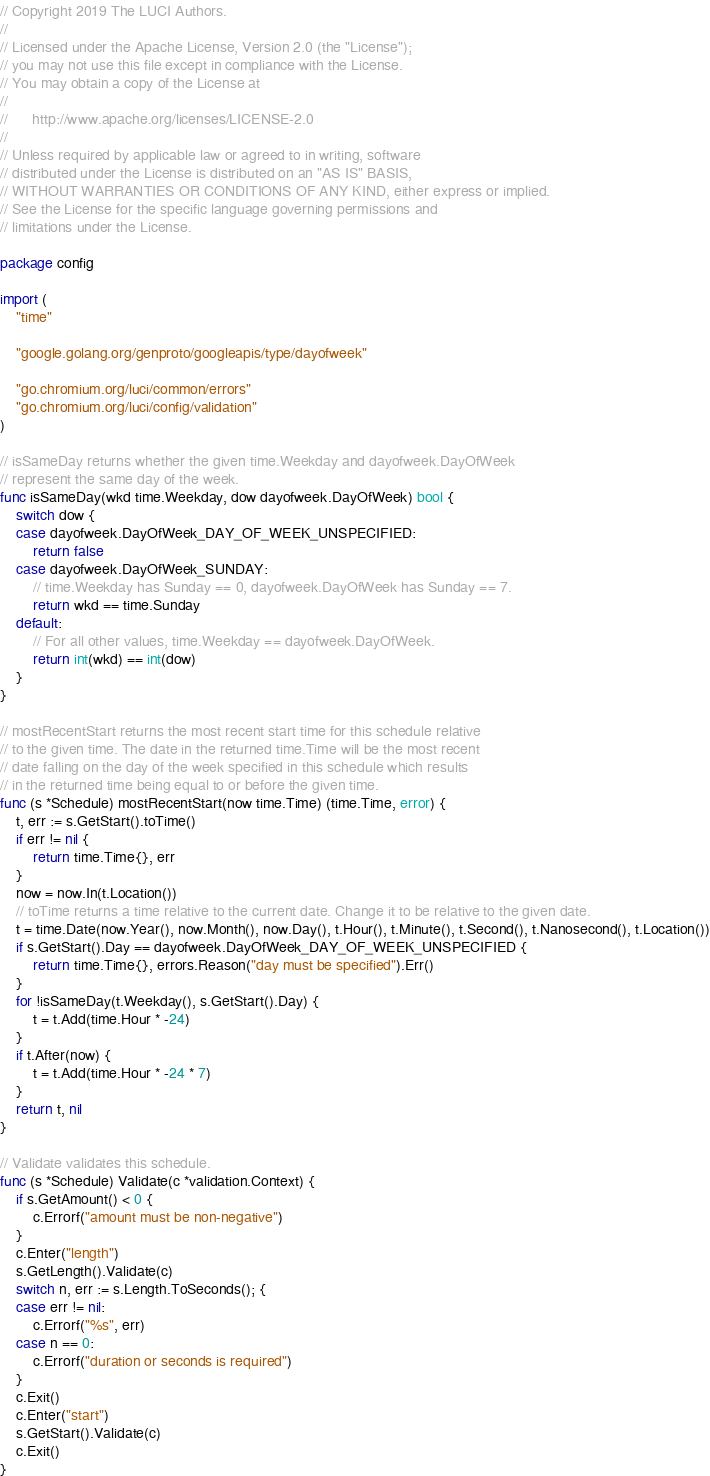Convert code to text. <code><loc_0><loc_0><loc_500><loc_500><_Go_>// Copyright 2019 The LUCI Authors.
//
// Licensed under the Apache License, Version 2.0 (the "License");
// you may not use this file except in compliance with the License.
// You may obtain a copy of the License at
//
//      http://www.apache.org/licenses/LICENSE-2.0
//
// Unless required by applicable law or agreed to in writing, software
// distributed under the License is distributed on an "AS IS" BASIS,
// WITHOUT WARRANTIES OR CONDITIONS OF ANY KIND, either express or implied.
// See the License for the specific language governing permissions and
// limitations under the License.

package config

import (
	"time"

	"google.golang.org/genproto/googleapis/type/dayofweek"

	"go.chromium.org/luci/common/errors"
	"go.chromium.org/luci/config/validation"
)

// isSameDay returns whether the given time.Weekday and dayofweek.DayOfWeek
// represent the same day of the week.
func isSameDay(wkd time.Weekday, dow dayofweek.DayOfWeek) bool {
	switch dow {
	case dayofweek.DayOfWeek_DAY_OF_WEEK_UNSPECIFIED:
		return false
	case dayofweek.DayOfWeek_SUNDAY:
		// time.Weekday has Sunday == 0, dayofweek.DayOfWeek has Sunday == 7.
		return wkd == time.Sunday
	default:
		// For all other values, time.Weekday == dayofweek.DayOfWeek.
		return int(wkd) == int(dow)
	}
}

// mostRecentStart returns the most recent start time for this schedule relative
// to the given time. The date in the returned time.Time will be the most recent
// date falling on the day of the week specified in this schedule which results
// in the returned time being equal to or before the given time.
func (s *Schedule) mostRecentStart(now time.Time) (time.Time, error) {
	t, err := s.GetStart().toTime()
	if err != nil {
		return time.Time{}, err
	}
	now = now.In(t.Location())
	// toTime returns a time relative to the current date. Change it to be relative to the given date.
	t = time.Date(now.Year(), now.Month(), now.Day(), t.Hour(), t.Minute(), t.Second(), t.Nanosecond(), t.Location())
	if s.GetStart().Day == dayofweek.DayOfWeek_DAY_OF_WEEK_UNSPECIFIED {
		return time.Time{}, errors.Reason("day must be specified").Err()
	}
	for !isSameDay(t.Weekday(), s.GetStart().Day) {
		t = t.Add(time.Hour * -24)
	}
	if t.After(now) {
		t = t.Add(time.Hour * -24 * 7)
	}
	return t, nil
}

// Validate validates this schedule.
func (s *Schedule) Validate(c *validation.Context) {
	if s.GetAmount() < 0 {
		c.Errorf("amount must be non-negative")
	}
	c.Enter("length")
	s.GetLength().Validate(c)
	switch n, err := s.Length.ToSeconds(); {
	case err != nil:
		c.Errorf("%s", err)
	case n == 0:
		c.Errorf("duration or seconds is required")
	}
	c.Exit()
	c.Enter("start")
	s.GetStart().Validate(c)
	c.Exit()
}
</code> 